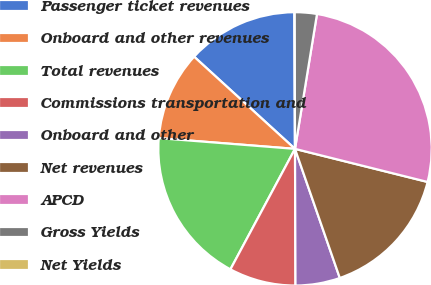Convert chart. <chart><loc_0><loc_0><loc_500><loc_500><pie_chart><fcel>Passenger ticket revenues<fcel>Onboard and other revenues<fcel>Total revenues<fcel>Commissions transportation and<fcel>Onboard and other<fcel>Net revenues<fcel>APCD<fcel>Gross Yields<fcel>Net Yields<nl><fcel>13.16%<fcel>10.53%<fcel>18.42%<fcel>7.89%<fcel>5.26%<fcel>15.79%<fcel>26.32%<fcel>2.63%<fcel>0.0%<nl></chart> 